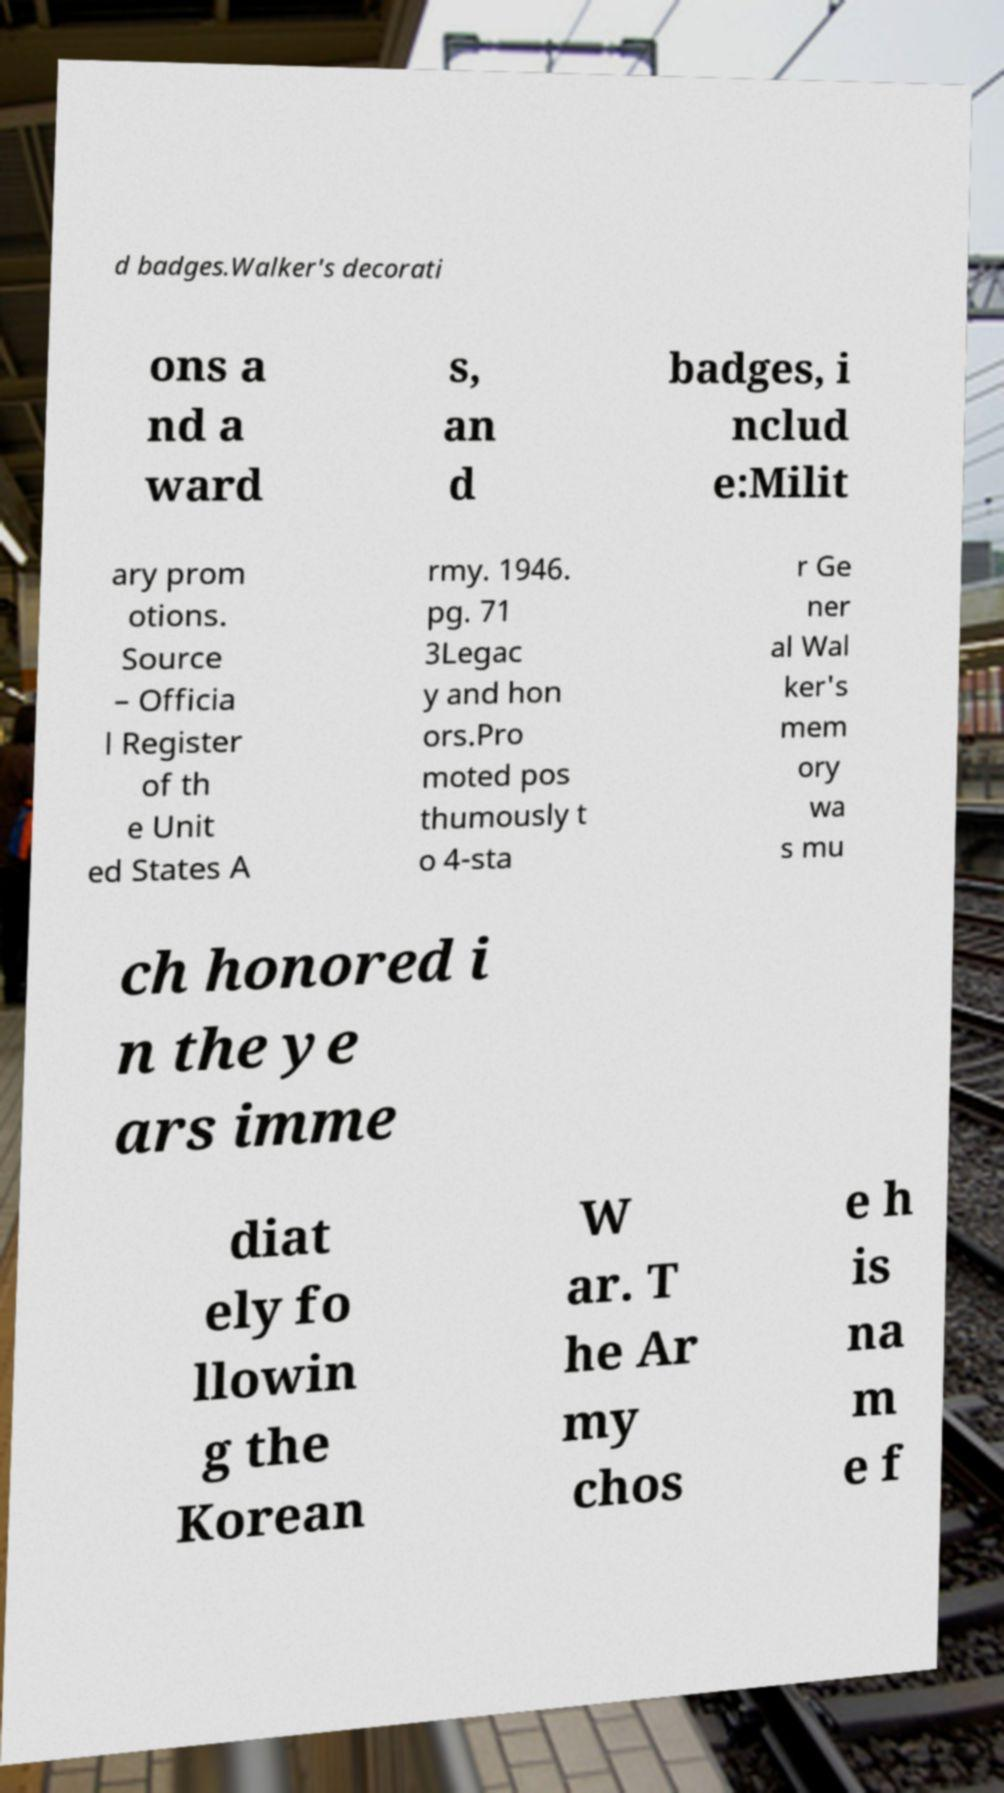Can you accurately transcribe the text from the provided image for me? d badges.Walker's decorati ons a nd a ward s, an d badges, i nclud e:Milit ary prom otions. Source – Officia l Register of th e Unit ed States A rmy. 1946. pg. 71 3Legac y and hon ors.Pro moted pos thumously t o 4-sta r Ge ner al Wal ker's mem ory wa s mu ch honored i n the ye ars imme diat ely fo llowin g the Korean W ar. T he Ar my chos e h is na m e f 